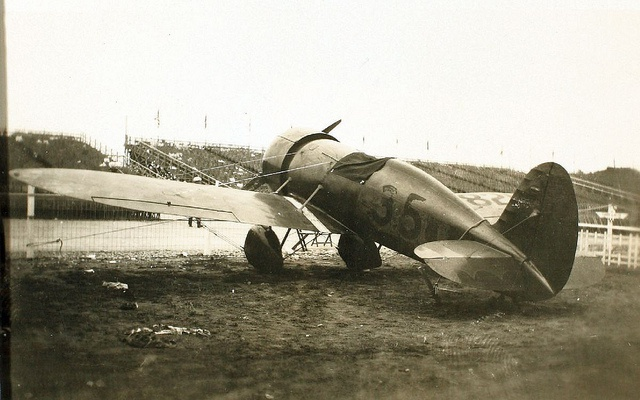Describe the objects in this image and their specific colors. I can see airplane in darkgray, black, darkgreen, beige, and tan tones and people in darkgray, gray, ivory, black, and darkgreen tones in this image. 